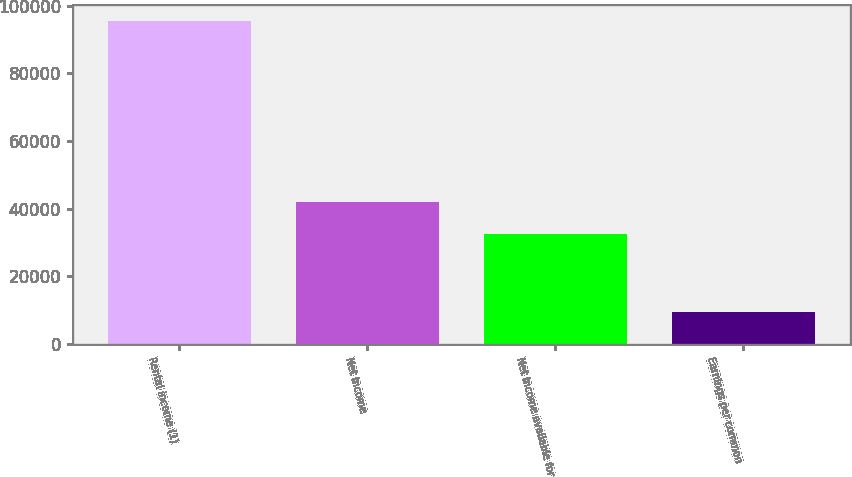Convert chart to OTSL. <chart><loc_0><loc_0><loc_500><loc_500><bar_chart><fcel>Rental income (1)<fcel>Net income<fcel>Net income available for<fcel>Earnings per common<nl><fcel>95402<fcel>42071.1<fcel>32531<fcel>9540.79<nl></chart> 